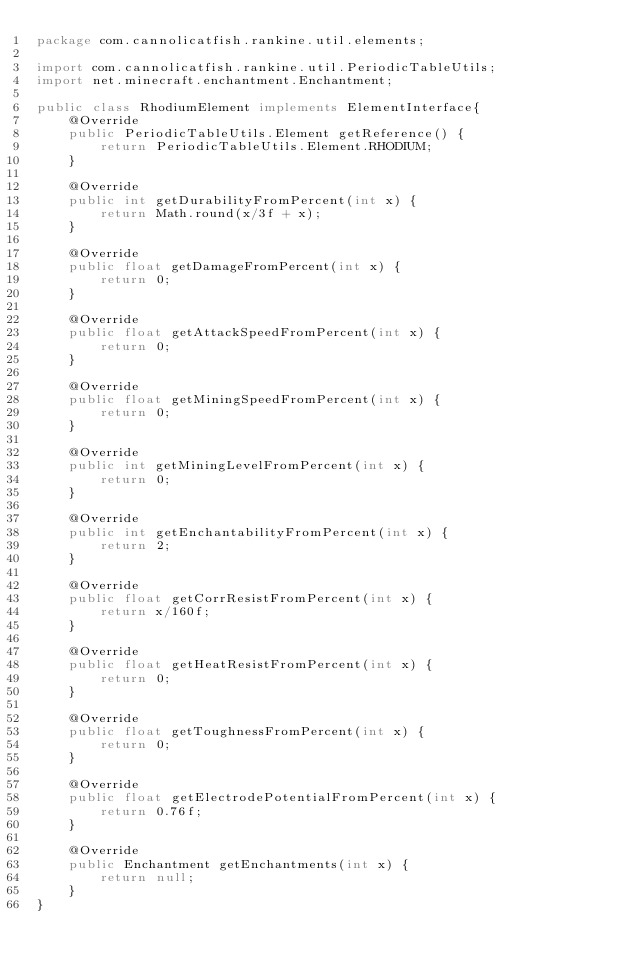Convert code to text. <code><loc_0><loc_0><loc_500><loc_500><_Java_>package com.cannolicatfish.rankine.util.elements;

import com.cannolicatfish.rankine.util.PeriodicTableUtils;
import net.minecraft.enchantment.Enchantment;

public class RhodiumElement implements ElementInterface{
    @Override
    public PeriodicTableUtils.Element getReference() {
        return PeriodicTableUtils.Element.RHODIUM;
    }

    @Override
    public int getDurabilityFromPercent(int x) {
        return Math.round(x/3f + x);
    }

    @Override
    public float getDamageFromPercent(int x) {
        return 0;
    }

    @Override
    public float getAttackSpeedFromPercent(int x) {
        return 0;
    }

    @Override
    public float getMiningSpeedFromPercent(int x) {
        return 0;
    }

    @Override
    public int getMiningLevelFromPercent(int x) {
        return 0;
    }

    @Override
    public int getEnchantabilityFromPercent(int x) {
        return 2;
    }

    @Override
    public float getCorrResistFromPercent(int x) {
        return x/160f;
    }

    @Override
    public float getHeatResistFromPercent(int x) {
        return 0;
    }

    @Override
    public float getToughnessFromPercent(int x) {
        return 0;
    }

    @Override
    public float getElectrodePotentialFromPercent(int x) {
        return 0.76f;
    }

    @Override
    public Enchantment getEnchantments(int x) {
        return null;
    }
}
</code> 